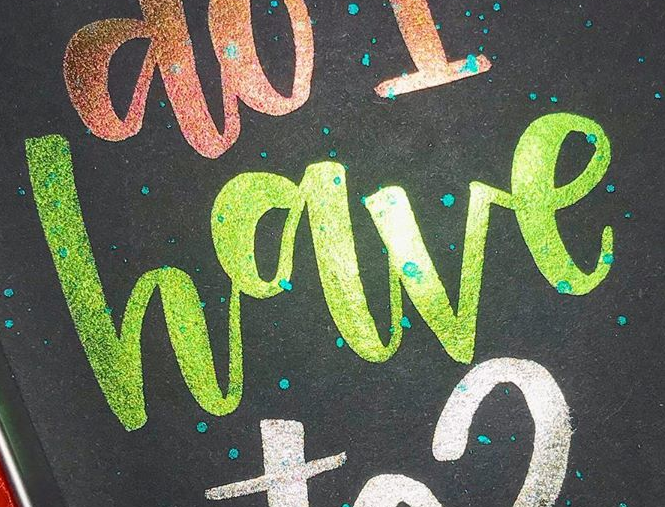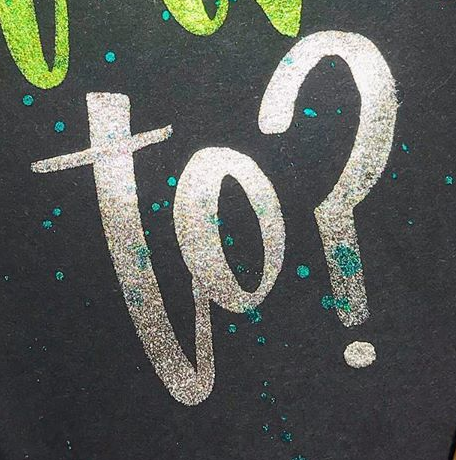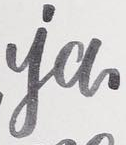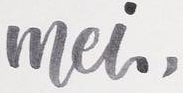What text is displayed in these images sequentially, separated by a semicolon? have; to?; ia; mei, 